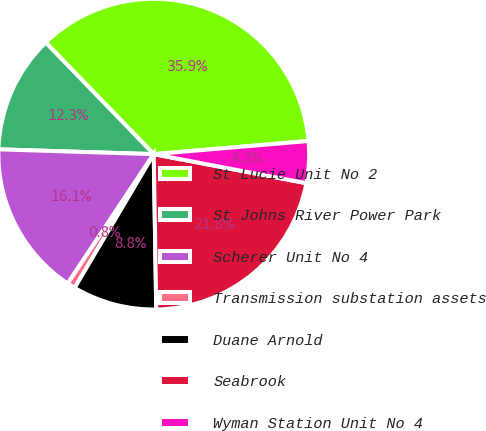Convert chart. <chart><loc_0><loc_0><loc_500><loc_500><pie_chart><fcel>St Lucie Unit No 2<fcel>St Johns River Power Park<fcel>Scherer Unit No 4<fcel>Transmission substation assets<fcel>Duane Arnold<fcel>Seabrook<fcel>Wyman Station Unit No 4<nl><fcel>35.89%<fcel>12.27%<fcel>16.15%<fcel>0.84%<fcel>8.76%<fcel>21.75%<fcel>4.34%<nl></chart> 